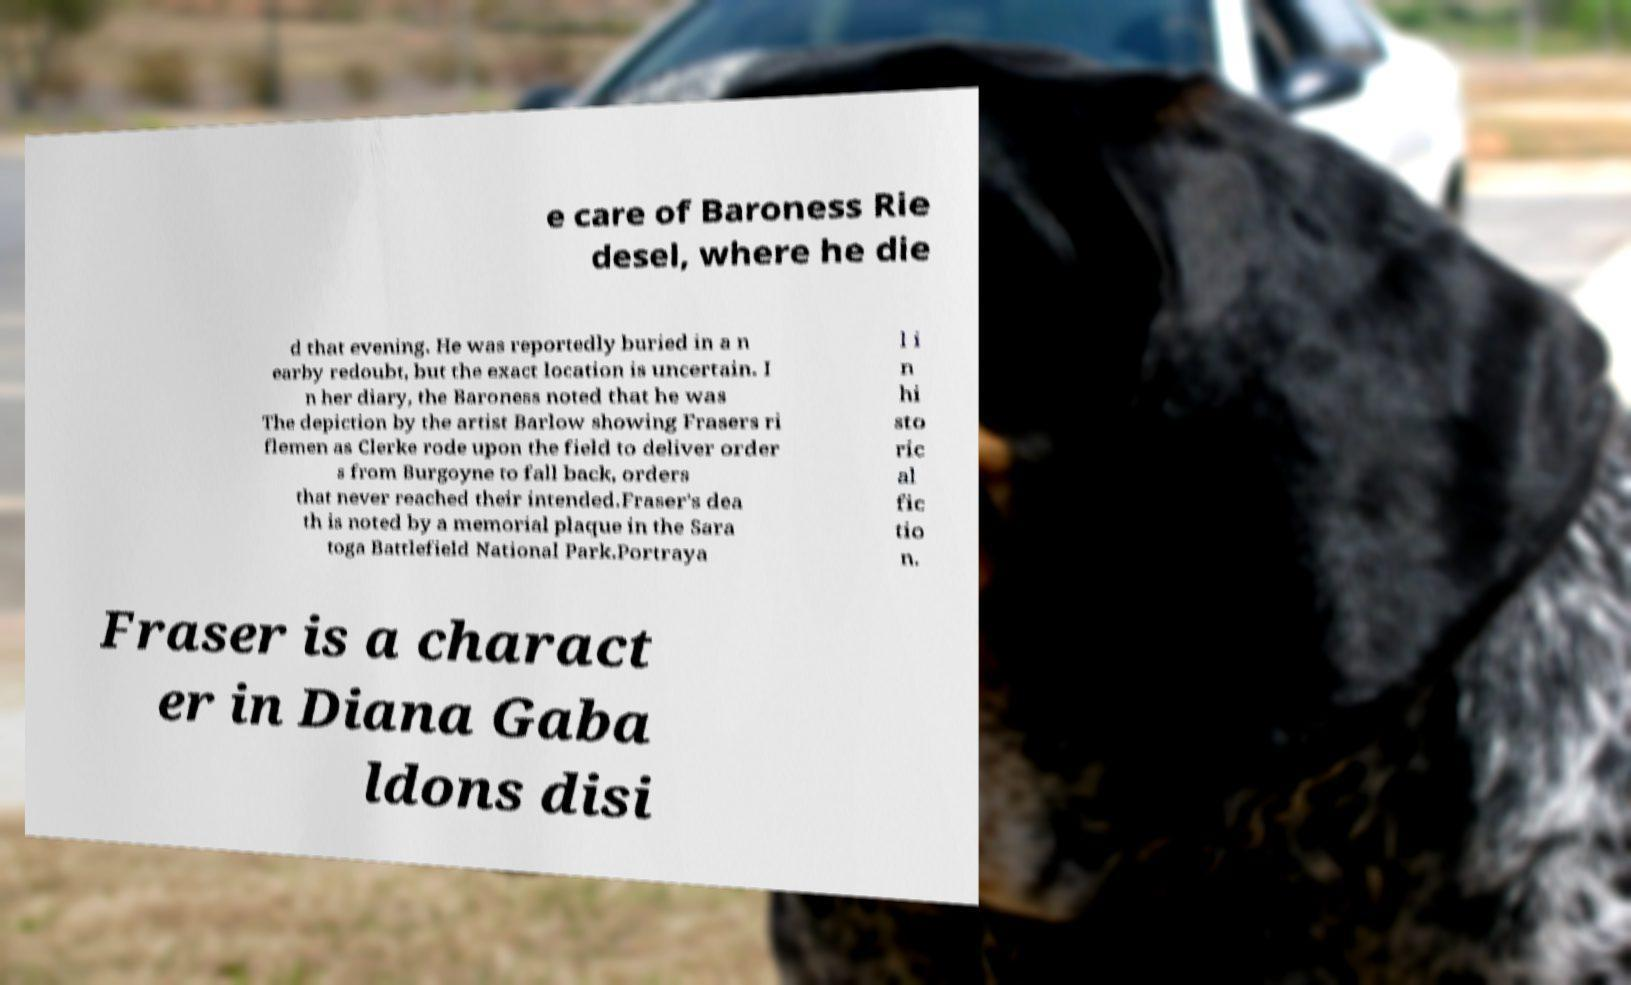Could you assist in decoding the text presented in this image and type it out clearly? e care of Baroness Rie desel, where he die d that evening. He was reportedly buried in a n earby redoubt, but the exact location is uncertain. I n her diary, the Baroness noted that he was The depiction by the artist Barlow showing Frasers ri flemen as Clerke rode upon the field to deliver order s from Burgoyne to fall back, orders that never reached their intended.Fraser's dea th is noted by a memorial plaque in the Sara toga Battlefield National Park.Portraya l i n hi sto ric al fic tio n. Fraser is a charact er in Diana Gaba ldons disi 